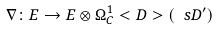Convert formula to latex. <formula><loc_0><loc_0><loc_500><loc_500>\nabla \colon E \to E \otimes \Omega ^ { 1 } _ { C } < D > ( \ s D ^ { \prime } )</formula> 